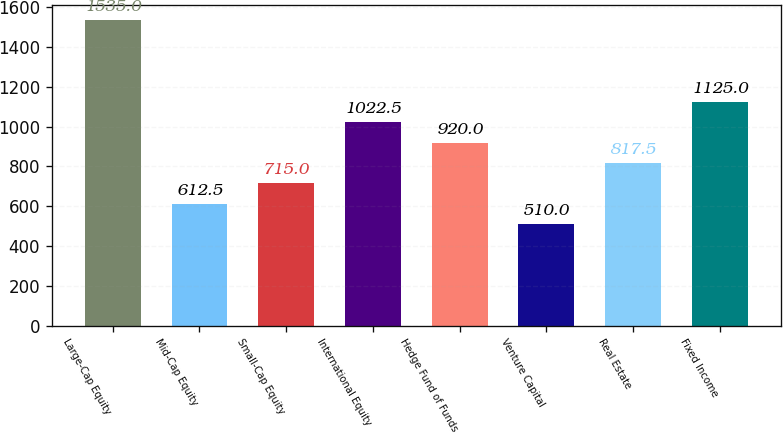<chart> <loc_0><loc_0><loc_500><loc_500><bar_chart><fcel>Large-Cap Equity<fcel>Mid-Cap Equity<fcel>Small-Cap Equity<fcel>International Equity<fcel>Hedge Fund of Funds<fcel>Venture Capital<fcel>Real Estate<fcel>Fixed Income<nl><fcel>1535<fcel>612.5<fcel>715<fcel>1022.5<fcel>920<fcel>510<fcel>817.5<fcel>1125<nl></chart> 